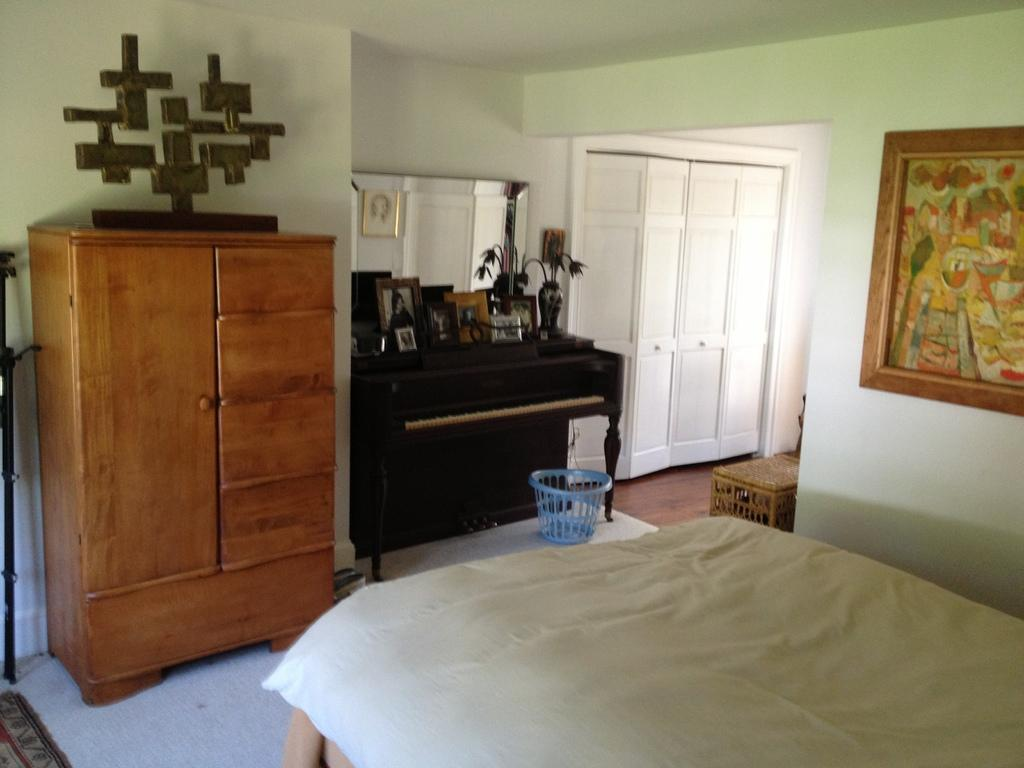What is located in the right corner of the image? There is a bed with a white color bed sheet in the right corner. What can be seen on top of the piano in the image? There are objects placed on the piano. What type of furniture is beside the piano? There is a wooden almirah beside the piano. How many pens are visible on the bed sheet in the image? There is no pen present in the image. What type of action is being performed on the wooden almirah in the image? There is no action being performed on the wooden almirah in the image; it is stationary. 